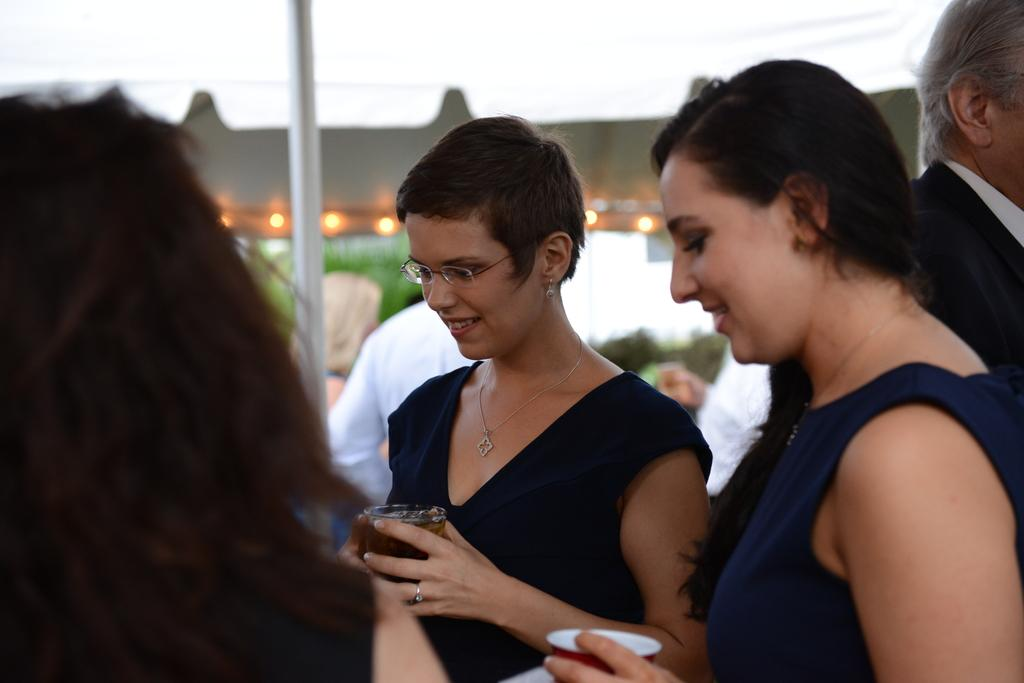Who or what can be seen in the image? There are people in the image. Where are the people located in the image? The people are standing beneath a tent. What are the people holding in their hands? The people are holding a glass of drink in their hand. What type of pies are being served for lunch in the image? There is no mention of pies or lunch in the image; it only shows people standing beneath a tent and holding a glass of drink. 